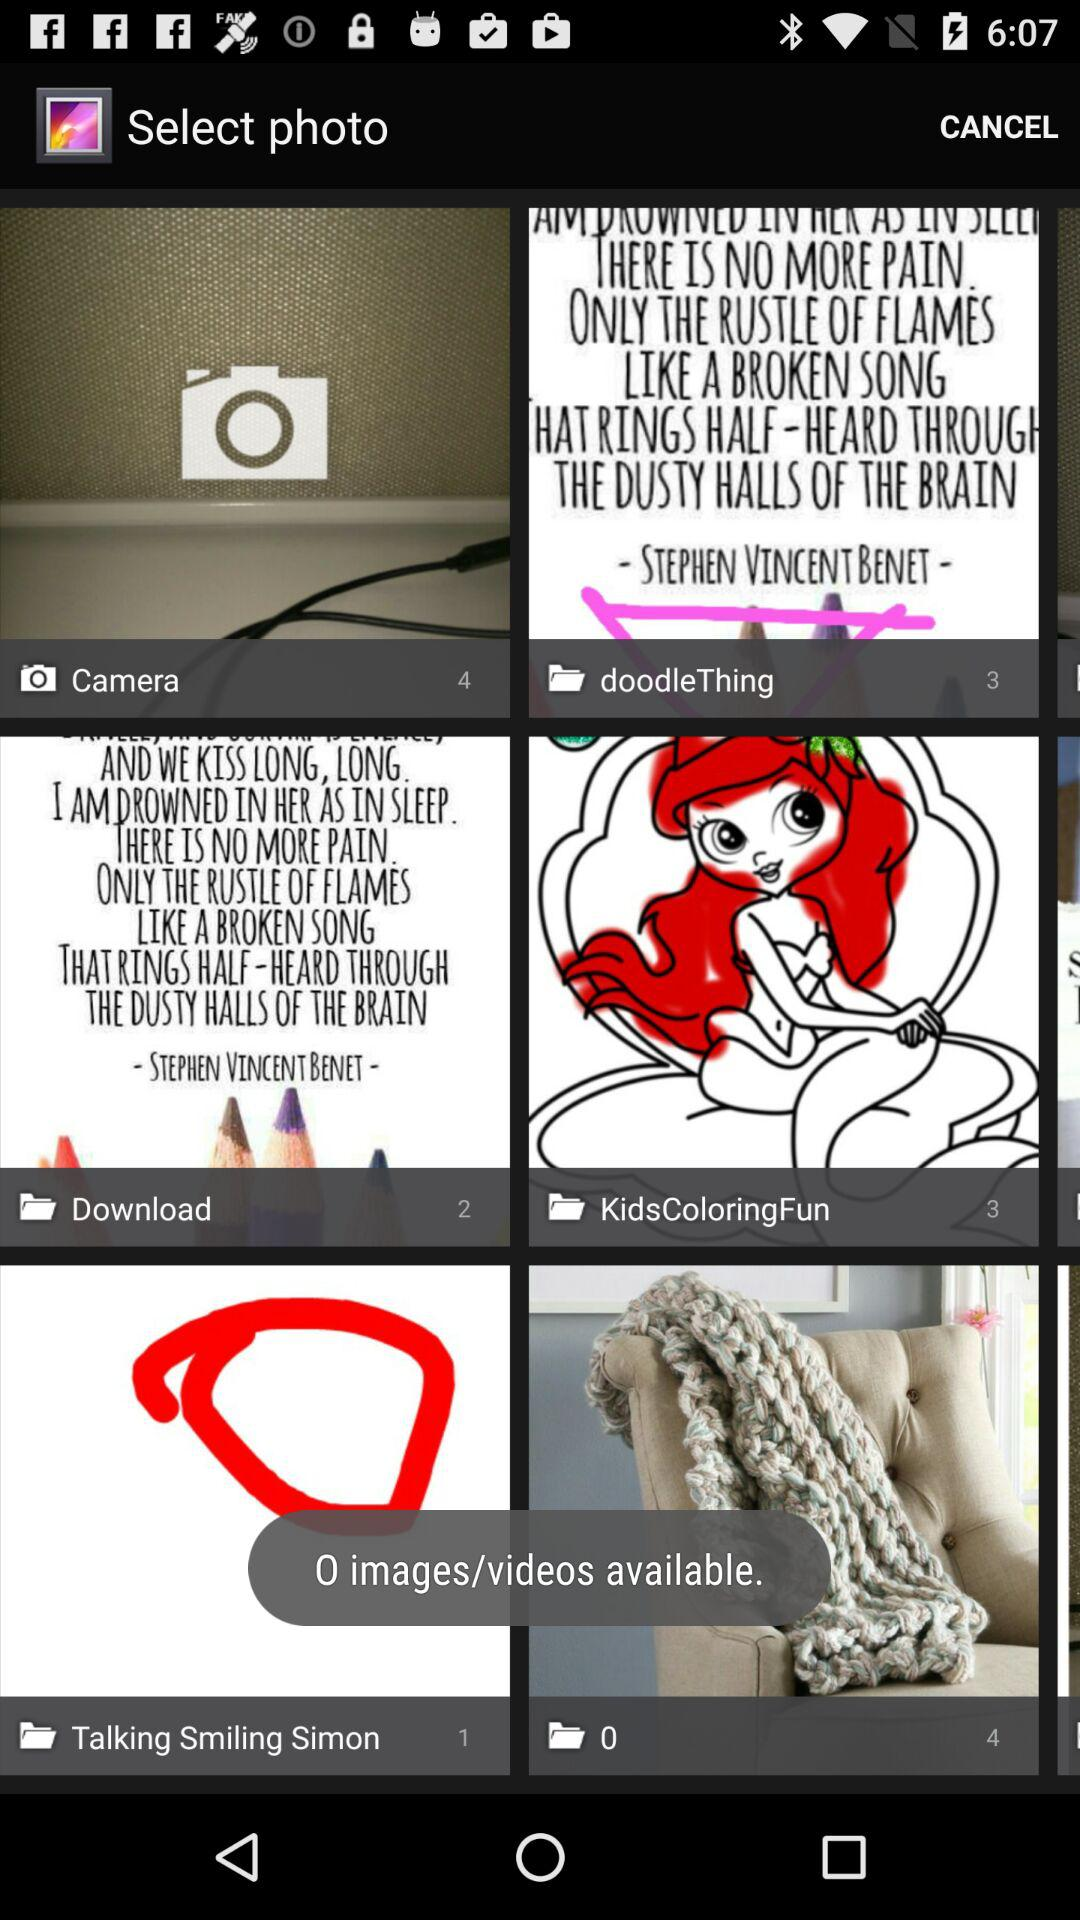Which photo was selected?
When the provided information is insufficient, respond with <no answer>. <no answer> 